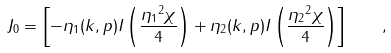<formula> <loc_0><loc_0><loc_500><loc_500>J _ { 0 } = \left [ - \eta _ { 1 } ( k , p ) I \left ( \frac { { \eta _ { 1 } } ^ { 2 } \chi } { 4 } \right ) + \eta _ { 2 } ( k , p ) I \left ( \frac { { \eta _ { 2 } } ^ { 2 } \chi } { 4 } \right ) \right ] \quad ,</formula> 